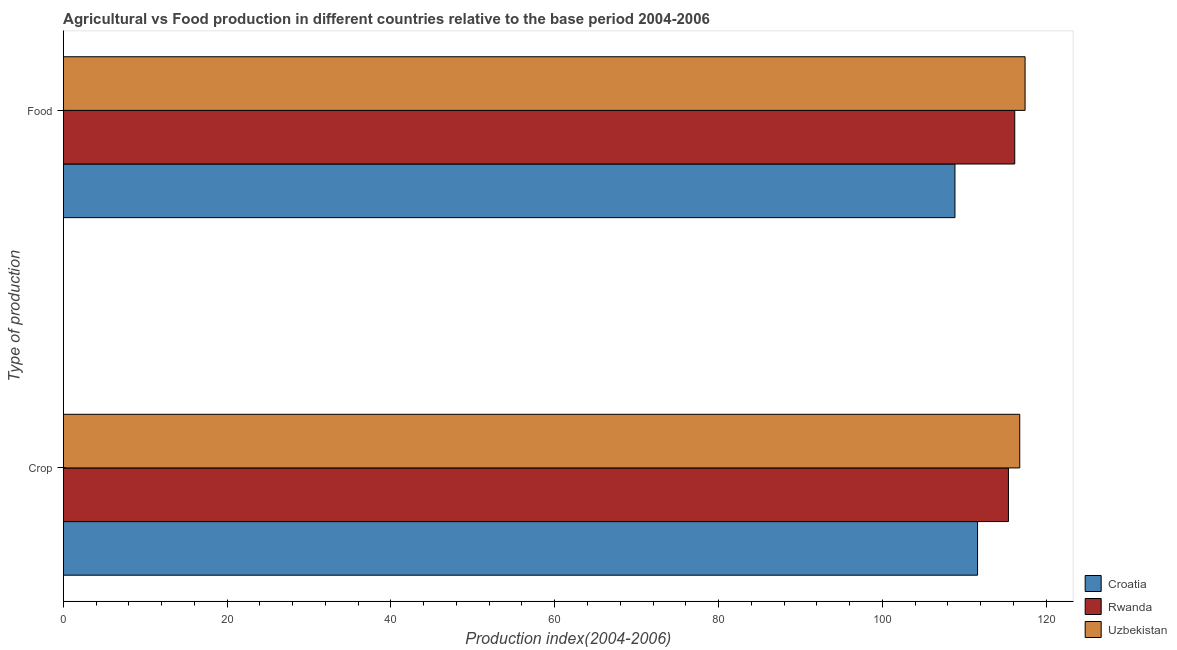How many different coloured bars are there?
Give a very brief answer. 3. Are the number of bars on each tick of the Y-axis equal?
Your answer should be very brief. Yes. How many bars are there on the 1st tick from the top?
Your response must be concise. 3. How many bars are there on the 1st tick from the bottom?
Your answer should be very brief. 3. What is the label of the 2nd group of bars from the top?
Offer a terse response. Crop. What is the food production index in Uzbekistan?
Offer a terse response. 117.42. Across all countries, what is the maximum crop production index?
Your answer should be compact. 116.77. Across all countries, what is the minimum crop production index?
Offer a terse response. 111.62. In which country was the crop production index maximum?
Make the answer very short. Uzbekistan. In which country was the crop production index minimum?
Your answer should be compact. Croatia. What is the total crop production index in the graph?
Offer a very short reply. 343.78. What is the difference between the food production index in Uzbekistan and that in Croatia?
Keep it short and to the point. 8.56. What is the difference between the food production index in Uzbekistan and the crop production index in Croatia?
Ensure brevity in your answer.  5.8. What is the average crop production index per country?
Provide a succinct answer. 114.59. What is the difference between the food production index and crop production index in Croatia?
Ensure brevity in your answer.  -2.76. In how many countries, is the food production index greater than 80 ?
Ensure brevity in your answer.  3. What is the ratio of the food production index in Uzbekistan to that in Croatia?
Provide a succinct answer. 1.08. Is the crop production index in Uzbekistan less than that in Rwanda?
Provide a short and direct response. No. What does the 1st bar from the top in Crop represents?
Offer a terse response. Uzbekistan. What does the 3rd bar from the bottom in Crop represents?
Give a very brief answer. Uzbekistan. How many bars are there?
Your answer should be very brief. 6. Are all the bars in the graph horizontal?
Offer a terse response. Yes. Are the values on the major ticks of X-axis written in scientific E-notation?
Offer a terse response. No. Does the graph contain any zero values?
Provide a short and direct response. No. Does the graph contain grids?
Provide a short and direct response. No. How many legend labels are there?
Provide a short and direct response. 3. What is the title of the graph?
Your answer should be compact. Agricultural vs Food production in different countries relative to the base period 2004-2006. Does "France" appear as one of the legend labels in the graph?
Offer a terse response. No. What is the label or title of the X-axis?
Make the answer very short. Production index(2004-2006). What is the label or title of the Y-axis?
Provide a succinct answer. Type of production. What is the Production index(2004-2006) of Croatia in Crop?
Provide a succinct answer. 111.62. What is the Production index(2004-2006) in Rwanda in Crop?
Your response must be concise. 115.39. What is the Production index(2004-2006) in Uzbekistan in Crop?
Provide a short and direct response. 116.77. What is the Production index(2004-2006) in Croatia in Food?
Your answer should be compact. 108.86. What is the Production index(2004-2006) in Rwanda in Food?
Offer a very short reply. 116.16. What is the Production index(2004-2006) in Uzbekistan in Food?
Provide a short and direct response. 117.42. Across all Type of production, what is the maximum Production index(2004-2006) of Croatia?
Provide a succinct answer. 111.62. Across all Type of production, what is the maximum Production index(2004-2006) of Rwanda?
Your answer should be compact. 116.16. Across all Type of production, what is the maximum Production index(2004-2006) of Uzbekistan?
Offer a terse response. 117.42. Across all Type of production, what is the minimum Production index(2004-2006) of Croatia?
Give a very brief answer. 108.86. Across all Type of production, what is the minimum Production index(2004-2006) in Rwanda?
Your answer should be compact. 115.39. Across all Type of production, what is the minimum Production index(2004-2006) in Uzbekistan?
Ensure brevity in your answer.  116.77. What is the total Production index(2004-2006) in Croatia in the graph?
Offer a terse response. 220.48. What is the total Production index(2004-2006) in Rwanda in the graph?
Your answer should be very brief. 231.55. What is the total Production index(2004-2006) of Uzbekistan in the graph?
Ensure brevity in your answer.  234.19. What is the difference between the Production index(2004-2006) of Croatia in Crop and that in Food?
Give a very brief answer. 2.76. What is the difference between the Production index(2004-2006) in Rwanda in Crop and that in Food?
Your response must be concise. -0.77. What is the difference between the Production index(2004-2006) of Uzbekistan in Crop and that in Food?
Your response must be concise. -0.65. What is the difference between the Production index(2004-2006) in Croatia in Crop and the Production index(2004-2006) in Rwanda in Food?
Make the answer very short. -4.54. What is the difference between the Production index(2004-2006) of Croatia in Crop and the Production index(2004-2006) of Uzbekistan in Food?
Offer a terse response. -5.8. What is the difference between the Production index(2004-2006) of Rwanda in Crop and the Production index(2004-2006) of Uzbekistan in Food?
Keep it short and to the point. -2.03. What is the average Production index(2004-2006) in Croatia per Type of production?
Your response must be concise. 110.24. What is the average Production index(2004-2006) in Rwanda per Type of production?
Provide a succinct answer. 115.78. What is the average Production index(2004-2006) of Uzbekistan per Type of production?
Provide a succinct answer. 117.09. What is the difference between the Production index(2004-2006) of Croatia and Production index(2004-2006) of Rwanda in Crop?
Your answer should be compact. -3.77. What is the difference between the Production index(2004-2006) of Croatia and Production index(2004-2006) of Uzbekistan in Crop?
Keep it short and to the point. -5.15. What is the difference between the Production index(2004-2006) of Rwanda and Production index(2004-2006) of Uzbekistan in Crop?
Your answer should be very brief. -1.38. What is the difference between the Production index(2004-2006) of Croatia and Production index(2004-2006) of Rwanda in Food?
Offer a very short reply. -7.3. What is the difference between the Production index(2004-2006) of Croatia and Production index(2004-2006) of Uzbekistan in Food?
Keep it short and to the point. -8.56. What is the difference between the Production index(2004-2006) of Rwanda and Production index(2004-2006) of Uzbekistan in Food?
Provide a short and direct response. -1.26. What is the ratio of the Production index(2004-2006) in Croatia in Crop to that in Food?
Your answer should be compact. 1.03. What is the ratio of the Production index(2004-2006) in Rwanda in Crop to that in Food?
Keep it short and to the point. 0.99. What is the ratio of the Production index(2004-2006) in Uzbekistan in Crop to that in Food?
Provide a short and direct response. 0.99. What is the difference between the highest and the second highest Production index(2004-2006) in Croatia?
Make the answer very short. 2.76. What is the difference between the highest and the second highest Production index(2004-2006) of Rwanda?
Give a very brief answer. 0.77. What is the difference between the highest and the second highest Production index(2004-2006) in Uzbekistan?
Your response must be concise. 0.65. What is the difference between the highest and the lowest Production index(2004-2006) in Croatia?
Offer a terse response. 2.76. What is the difference between the highest and the lowest Production index(2004-2006) in Rwanda?
Your answer should be compact. 0.77. What is the difference between the highest and the lowest Production index(2004-2006) of Uzbekistan?
Ensure brevity in your answer.  0.65. 